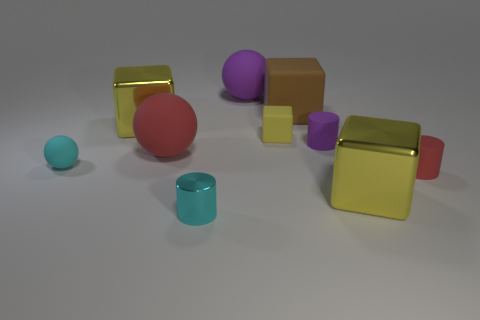Subtract all tiny matte cylinders. How many cylinders are left? 1 Subtract all red cylinders. How many yellow blocks are left? 3 Subtract all brown blocks. How many blocks are left? 3 Subtract 2 blocks. How many blocks are left? 2 Subtract all blue blocks. Subtract all gray cylinders. How many blocks are left? 4 Subtract all cubes. How many objects are left? 6 Subtract all blue rubber blocks. Subtract all small red objects. How many objects are left? 9 Add 2 large yellow metallic blocks. How many large yellow metallic blocks are left? 4 Add 1 large rubber balls. How many large rubber balls exist? 3 Subtract 0 yellow cylinders. How many objects are left? 10 